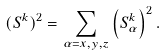<formula> <loc_0><loc_0><loc_500><loc_500>( { S } ^ { k } ) ^ { 2 } = \sum _ { \alpha = x , y , z } \left ( { S } _ { \alpha } ^ { k } \right ) ^ { 2 } .</formula> 